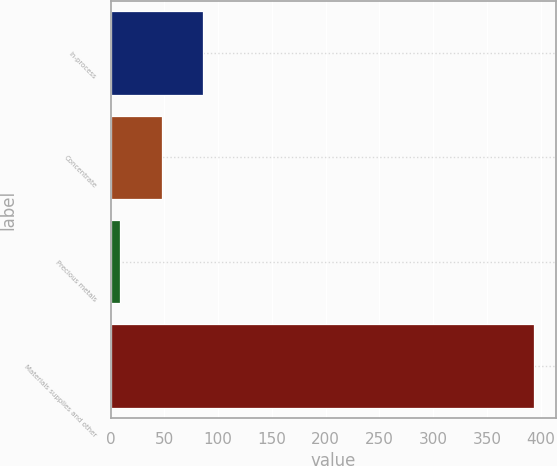<chart> <loc_0><loc_0><loc_500><loc_500><bar_chart><fcel>In-process<fcel>Concentrate<fcel>Precious metals<fcel>Materials supplies and other<nl><fcel>86<fcel>47.5<fcel>9<fcel>394<nl></chart> 